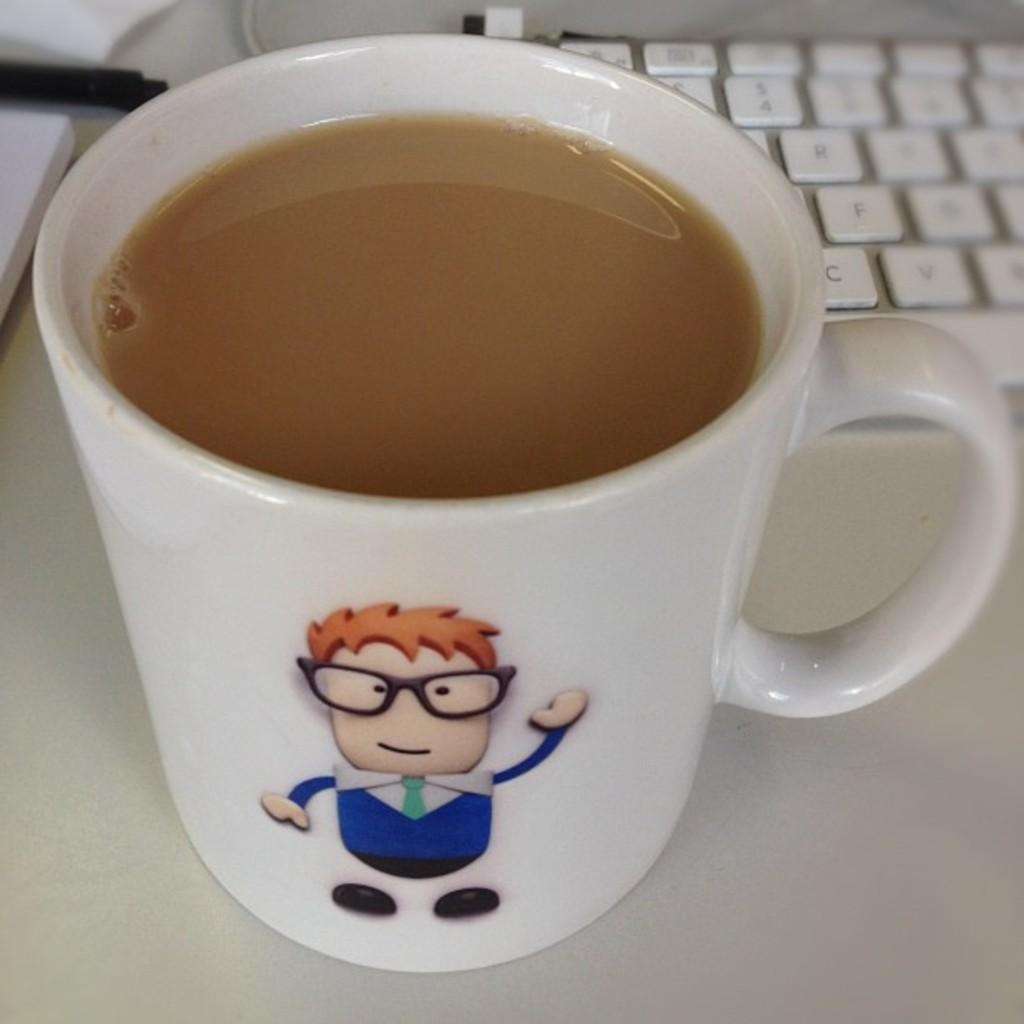What is in the cup that is visible in the image? There is a beverage in a cup in the image. What object related to typing or inputting data can be seen in the image? There is a keyboard on a surface in the image. Where is the zoo located in the image? There is no zoo present in the image. What type of donkey can be seen interacting with the keyboard in the image? There is no donkey present in the image, and therefore no such interaction can be observed. 